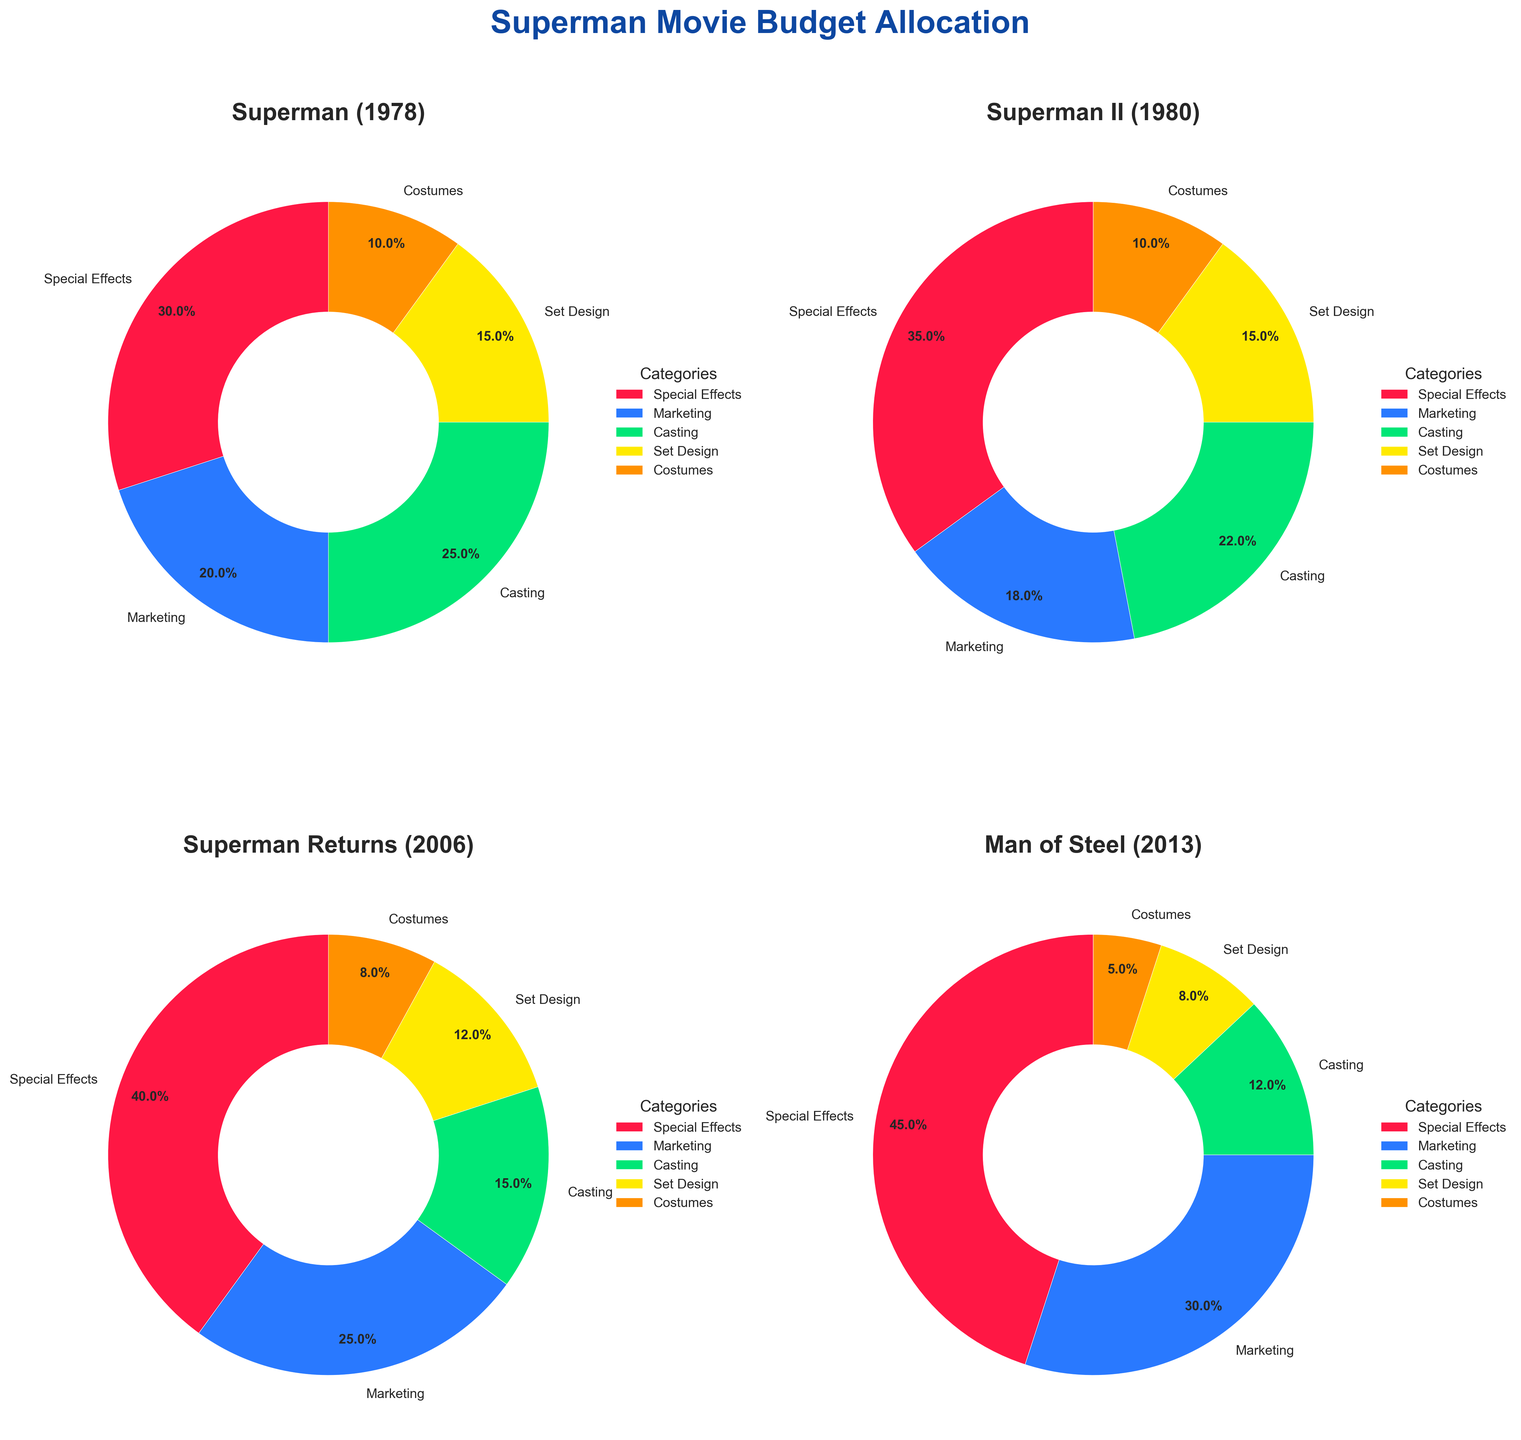Which Superman movie allocated the largest percentage of its budget to special effects? Compare the percentages allocated to special effects for each movie. "Man of Steel (2013)" allocated 45%, which is the highest compared to "Superman (1978)" at 30%, "Superman II (1980)" at 35%, and "Superman Returns (2006)" at 40%.
Answer: Man of Steel (2013) What is the total percentage of the budget allocated to marketing across all four Superman movies? Sum the marketing budgets of each movie: 20% (Superman 1978) + 18% (Superman II 1980) + 25% (Superman Returns 2006) + 30% (Man of Steel 2013) = 93%.
Answer: 93% Which category consistently received 10% of the budget in both Superman (1978) and Superman II (1980)? Check the budget allocations for both Superman (1978) and Superman II (1980). "Costumes" received 10% in both cases.
Answer: Costumes Which movie had the smallest percentage allocation for casting, and what was the percentage? Identify the casting budget for each movie and find the smallest value. "Man of Steel (2013)" allocated 12%, which is the smallest.
Answer: Man of Steel (2013) Could you compare the budgeting for set design in Superman Returns (2006) and Man of Steel (2013)? Compare the percentages: "Superman Returns (2006)" allocated 12% and "Man of Steel (2013)" allocated 8% for set design.
Answer: Superman Returns (2006): 12%, Man of Steel (2013): 8% Among all movies, which category had the highest single percentage allocation, and in which movie did it occur? Identify the highest single percentage allocation: "Man of Steel (2013)" allocated 45% to special effects, which is the highest.
Answer: Special Effects in Man of Steel (2013) How does the total budget percentage for casting compare between "Superman (1978)" and "Man of Steel (2013)"? Compare the casting budgets: "Superman (1978)" allocated 25%, while "Man of Steel (2013)" allocated 12%.
Answer: Superman (1978) allocated 13% more For Superman II (1980), what is the combined percentage allocated to set design and costumes? Add the percentages for set design and costumes in Superman II (1980): 15% (set design) + 10% (costumes) = 25%.
Answer: 25% 